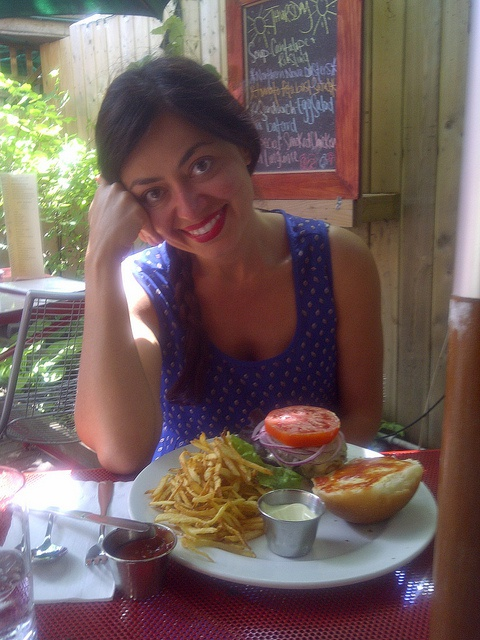Describe the objects in this image and their specific colors. I can see people in teal, maroon, black, and brown tones, dining table in teal, maroon, black, and purple tones, chair in teal, gray, darkgray, olive, and purple tones, cup in teal, lavender, purple, and gray tones, and sandwich in teal, brown, gray, and maroon tones in this image. 